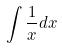<formula> <loc_0><loc_0><loc_500><loc_500>\int \frac { 1 } { x } d x</formula> 